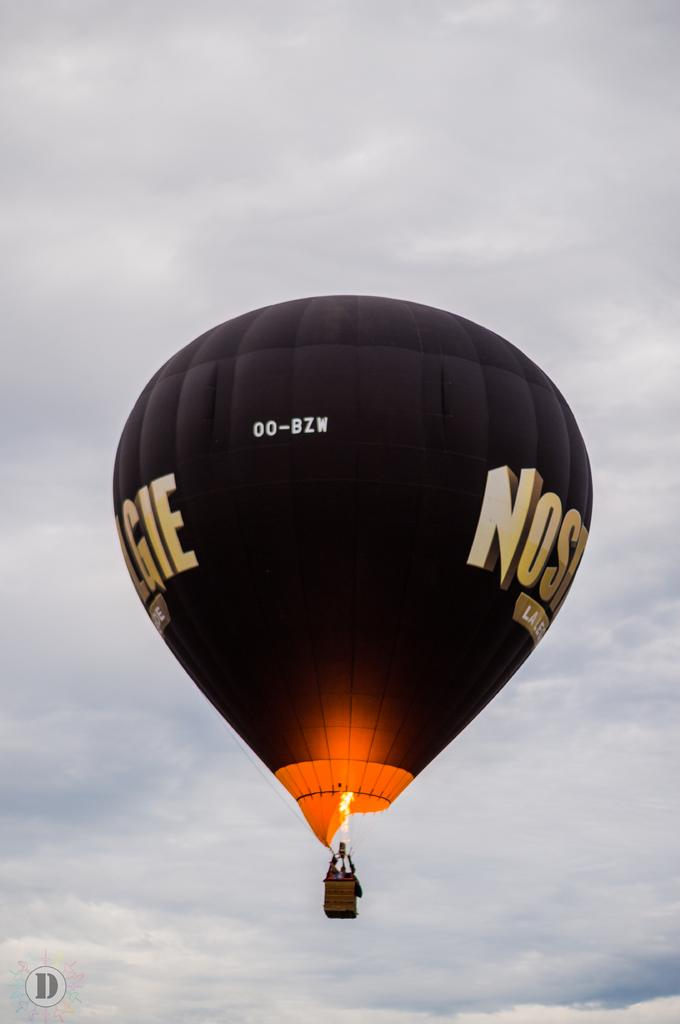Provide a one-sentence caption for the provided image. A hot air balloon flying with 00-BZW written on it. 